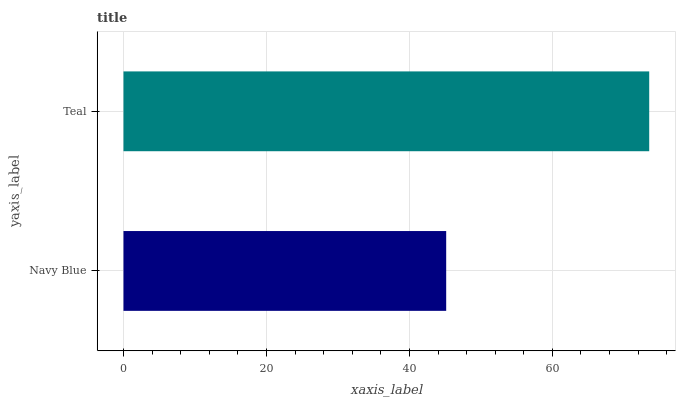Is Navy Blue the minimum?
Answer yes or no. Yes. Is Teal the maximum?
Answer yes or no. Yes. Is Teal the minimum?
Answer yes or no. No. Is Teal greater than Navy Blue?
Answer yes or no. Yes. Is Navy Blue less than Teal?
Answer yes or no. Yes. Is Navy Blue greater than Teal?
Answer yes or no. No. Is Teal less than Navy Blue?
Answer yes or no. No. Is Teal the high median?
Answer yes or no. Yes. Is Navy Blue the low median?
Answer yes or no. Yes. Is Navy Blue the high median?
Answer yes or no. No. Is Teal the low median?
Answer yes or no. No. 